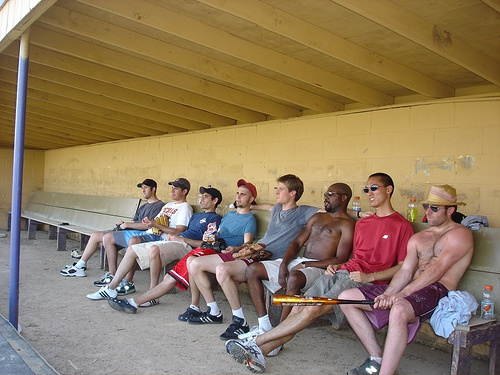Describe the objects in this image and their specific colors. I can see people in lavender, gray, darkgray, and black tones, people in lavender, darkgray, gray, and lightpink tones, people in lavender, brown, darkgray, and gray tones, bench in lavender, darkgray, and gray tones, and bench in lavender, gray, and black tones in this image. 